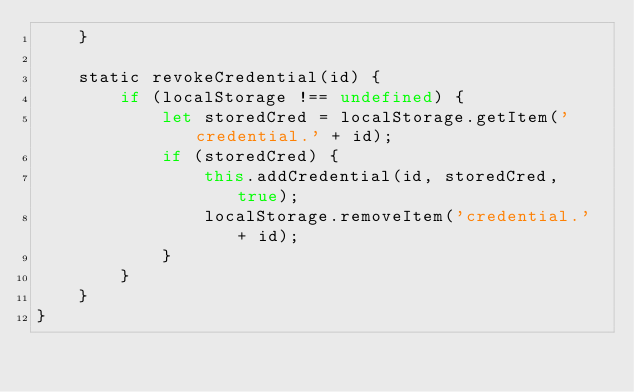<code> <loc_0><loc_0><loc_500><loc_500><_JavaScript_>    }

    static revokeCredential(id) {
        if (localStorage !== undefined) {
            let storedCred = localStorage.getItem('credential.' + id);
            if (storedCred) {
                this.addCredential(id, storedCred, true);
                localStorage.removeItem('credential.' + id);
            }
        }
    }
}
</code> 